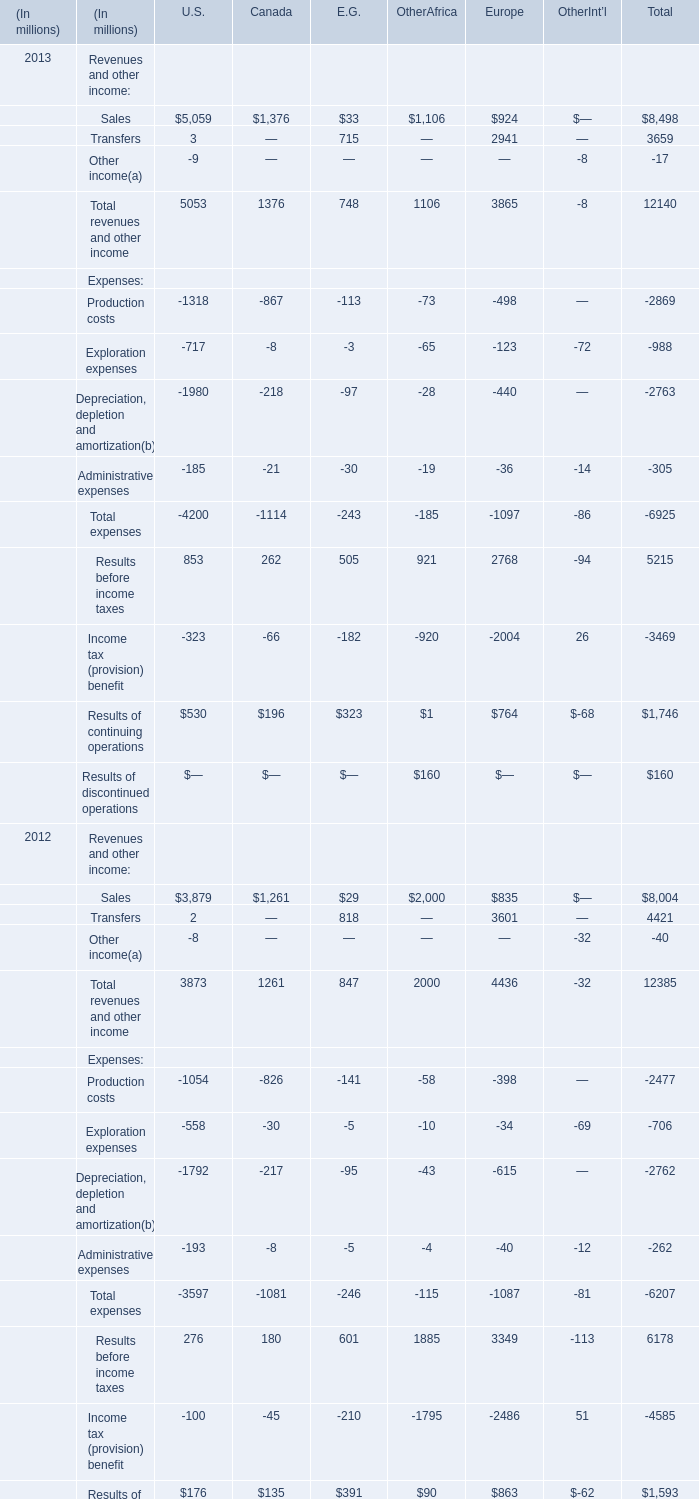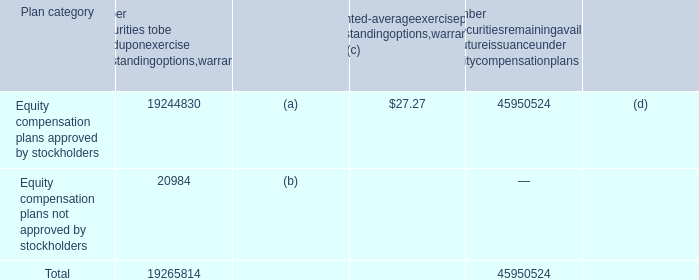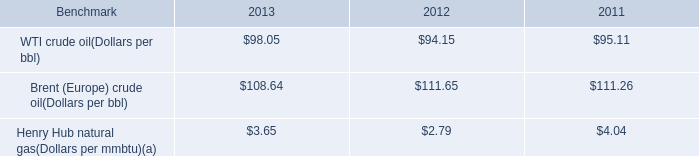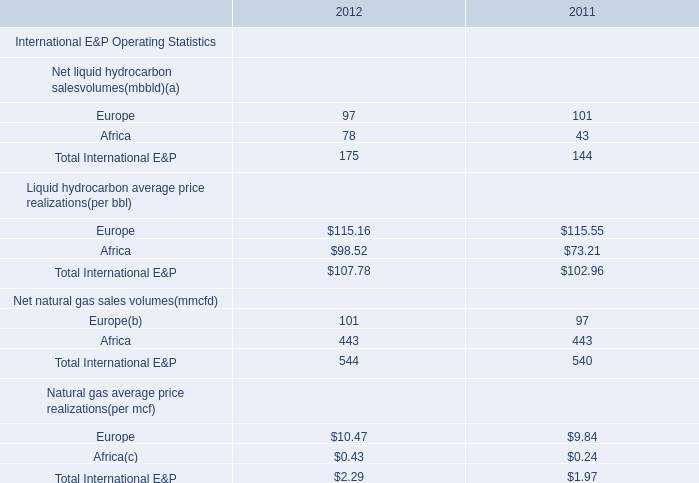Does Sales in Other Afirca keeps increasing each year between 2012 and 2013? 
Answer: NO. 